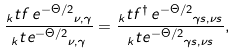<formula> <loc_0><loc_0><loc_500><loc_500>\frac { _ { k } t { f \, e ^ { - \Theta / 2 } } _ { \nu , \gamma } } { _ { k } t { e ^ { - \Theta / 2 } } _ { \nu , \gamma } } = \frac { _ { k } t { f ^ { \dagger } \, e ^ { - \Theta / 2 } } _ { \gamma s , \nu s } } { _ { k } t { e ^ { - \Theta / 2 } } _ { \gamma s , \nu s } } ,</formula> 